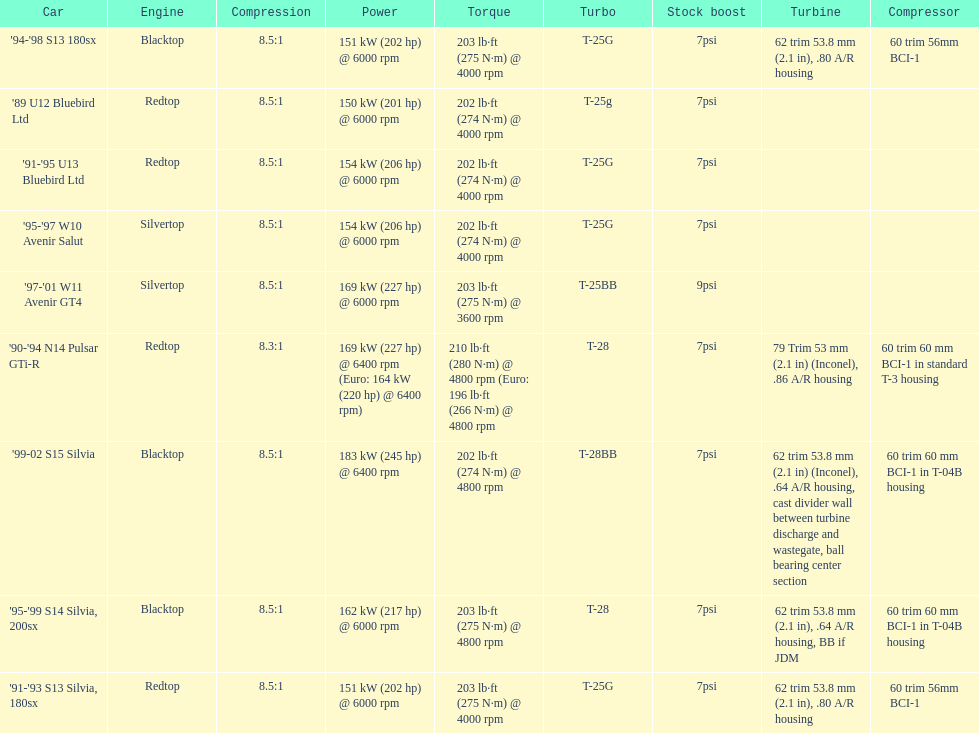How many models used the redtop engine? 4. 